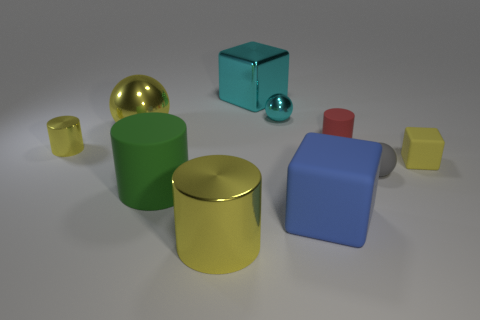There is a metal object that is the same color as the shiny cube; what is its shape?
Provide a short and direct response. Sphere. Is there a large block of the same color as the tiny shiny sphere?
Provide a succinct answer. Yes. The small cylinder that is to the left of the yellow shiny ball is what color?
Provide a short and direct response. Yellow. What number of green things are there?
Give a very brief answer. 1. There is another cyan thing that is made of the same material as the tiny cyan thing; what shape is it?
Offer a very short reply. Cube. There is a ball right of the blue object; is its color the same as the big block in front of the big green thing?
Provide a succinct answer. No. Are there an equal number of green rubber cylinders on the left side of the big metallic cylinder and big shiny blocks?
Your answer should be very brief. Yes. There is a yellow block; what number of small yellow things are behind it?
Your response must be concise. 1. What size is the blue object?
Your response must be concise. Large. What color is the tiny sphere that is made of the same material as the blue thing?
Ensure brevity in your answer.  Gray. 